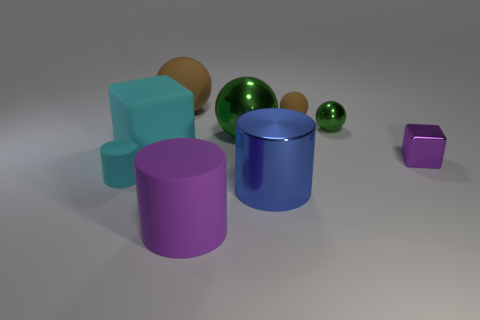There is a shiny ball that is left of the big blue metal cylinder; is its color the same as the tiny metal ball?
Provide a succinct answer. Yes. There is a cube that is behind the purple shiny block; does it have the same color as the small object that is on the left side of the blue object?
Ensure brevity in your answer.  Yes. What is the color of the shiny ball to the left of the tiny metal sphere?
Your answer should be very brief. Green. There is a purple object that is behind the cyan cylinder; are there any tiny shiny balls on the left side of it?
Keep it short and to the point. Yes. Do the small cyan thing and the shiny thing that is in front of the purple shiny block have the same shape?
Offer a terse response. Yes. There is a metal thing that is left of the metal block and in front of the cyan block; how big is it?
Your answer should be compact. Large. Is there a tiny blue object made of the same material as the tiny cyan thing?
Provide a succinct answer. No. There is a rubber cylinder that is the same color as the tiny cube; what size is it?
Offer a terse response. Large. What is the material of the purple object in front of the purple cube behind the small cyan cylinder?
Your answer should be very brief. Rubber. How many rubber blocks have the same color as the small matte cylinder?
Make the answer very short. 1. 